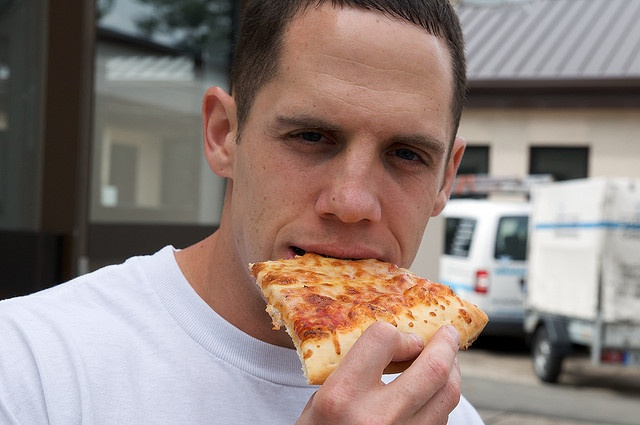Describe the objects in this image and their specific colors. I can see people in black, gray, lavender, lightpink, and salmon tones, pizza in black, tan, and brown tones, car in black, darkgray, lightgray, and gray tones, and truck in black, lightgray, darkgray, and gray tones in this image. 